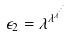Convert formula to latex. <formula><loc_0><loc_0><loc_500><loc_500>\epsilon _ { 2 } = \lambda ^ { \lambda ^ { \lambda ^ { \cdot ^ { \cdot ^ { \cdot } } } } }</formula> 